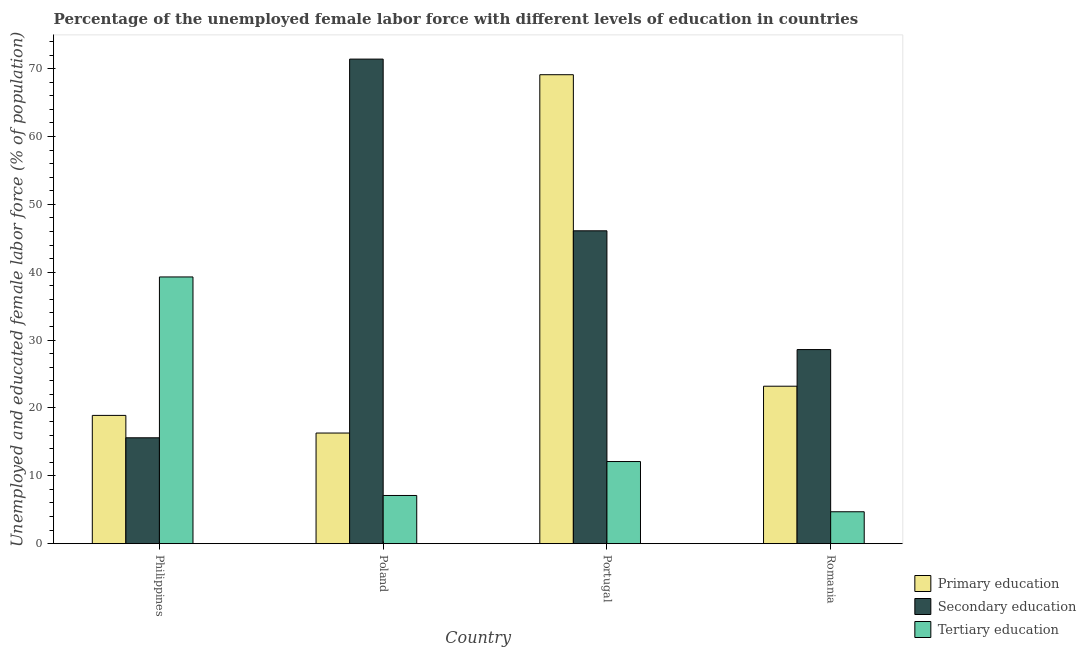How many different coloured bars are there?
Your answer should be compact. 3. Are the number of bars per tick equal to the number of legend labels?
Make the answer very short. Yes. Are the number of bars on each tick of the X-axis equal?
Give a very brief answer. Yes. What is the label of the 1st group of bars from the left?
Make the answer very short. Philippines. What is the percentage of female labor force who received primary education in Philippines?
Your answer should be compact. 18.9. Across all countries, what is the maximum percentage of female labor force who received secondary education?
Provide a succinct answer. 71.4. Across all countries, what is the minimum percentage of female labor force who received tertiary education?
Your answer should be compact. 4.7. In which country was the percentage of female labor force who received tertiary education maximum?
Your answer should be very brief. Philippines. In which country was the percentage of female labor force who received secondary education minimum?
Your response must be concise. Philippines. What is the total percentage of female labor force who received secondary education in the graph?
Keep it short and to the point. 161.7. What is the difference between the percentage of female labor force who received tertiary education in Portugal and that in Romania?
Your answer should be compact. 7.4. What is the difference between the percentage of female labor force who received secondary education in Portugal and the percentage of female labor force who received tertiary education in Poland?
Offer a terse response. 39. What is the average percentage of female labor force who received tertiary education per country?
Your answer should be compact. 15.8. What is the difference between the percentage of female labor force who received tertiary education and percentage of female labor force who received primary education in Poland?
Your response must be concise. -9.2. What is the ratio of the percentage of female labor force who received secondary education in Philippines to that in Romania?
Provide a succinct answer. 0.55. Is the percentage of female labor force who received secondary education in Poland less than that in Romania?
Offer a terse response. No. Is the difference between the percentage of female labor force who received secondary education in Poland and Romania greater than the difference between the percentage of female labor force who received tertiary education in Poland and Romania?
Offer a very short reply. Yes. What is the difference between the highest and the second highest percentage of female labor force who received primary education?
Give a very brief answer. 45.9. What is the difference between the highest and the lowest percentage of female labor force who received primary education?
Ensure brevity in your answer.  52.8. In how many countries, is the percentage of female labor force who received secondary education greater than the average percentage of female labor force who received secondary education taken over all countries?
Offer a terse response. 2. Is the sum of the percentage of female labor force who received primary education in Philippines and Portugal greater than the maximum percentage of female labor force who received secondary education across all countries?
Offer a terse response. Yes. What does the 1st bar from the left in Philippines represents?
Offer a very short reply. Primary education. What does the 2nd bar from the right in Philippines represents?
Your response must be concise. Secondary education. Is it the case that in every country, the sum of the percentage of female labor force who received primary education and percentage of female labor force who received secondary education is greater than the percentage of female labor force who received tertiary education?
Keep it short and to the point. No. Are all the bars in the graph horizontal?
Offer a terse response. No. What is the difference between two consecutive major ticks on the Y-axis?
Offer a very short reply. 10. Are the values on the major ticks of Y-axis written in scientific E-notation?
Provide a short and direct response. No. Does the graph contain any zero values?
Offer a terse response. No. Does the graph contain grids?
Provide a succinct answer. No. What is the title of the graph?
Keep it short and to the point. Percentage of the unemployed female labor force with different levels of education in countries. Does "Food" appear as one of the legend labels in the graph?
Your answer should be compact. No. What is the label or title of the X-axis?
Your response must be concise. Country. What is the label or title of the Y-axis?
Your answer should be very brief. Unemployed and educated female labor force (% of population). What is the Unemployed and educated female labor force (% of population) of Primary education in Philippines?
Your answer should be compact. 18.9. What is the Unemployed and educated female labor force (% of population) of Secondary education in Philippines?
Make the answer very short. 15.6. What is the Unemployed and educated female labor force (% of population) of Tertiary education in Philippines?
Your response must be concise. 39.3. What is the Unemployed and educated female labor force (% of population) of Primary education in Poland?
Offer a terse response. 16.3. What is the Unemployed and educated female labor force (% of population) in Secondary education in Poland?
Offer a terse response. 71.4. What is the Unemployed and educated female labor force (% of population) of Tertiary education in Poland?
Your answer should be very brief. 7.1. What is the Unemployed and educated female labor force (% of population) in Primary education in Portugal?
Provide a succinct answer. 69.1. What is the Unemployed and educated female labor force (% of population) of Secondary education in Portugal?
Offer a very short reply. 46.1. What is the Unemployed and educated female labor force (% of population) in Tertiary education in Portugal?
Your answer should be compact. 12.1. What is the Unemployed and educated female labor force (% of population) in Primary education in Romania?
Keep it short and to the point. 23.2. What is the Unemployed and educated female labor force (% of population) in Secondary education in Romania?
Offer a terse response. 28.6. What is the Unemployed and educated female labor force (% of population) in Tertiary education in Romania?
Make the answer very short. 4.7. Across all countries, what is the maximum Unemployed and educated female labor force (% of population) in Primary education?
Ensure brevity in your answer.  69.1. Across all countries, what is the maximum Unemployed and educated female labor force (% of population) of Secondary education?
Give a very brief answer. 71.4. Across all countries, what is the maximum Unemployed and educated female labor force (% of population) in Tertiary education?
Your answer should be compact. 39.3. Across all countries, what is the minimum Unemployed and educated female labor force (% of population) in Primary education?
Your answer should be compact. 16.3. Across all countries, what is the minimum Unemployed and educated female labor force (% of population) of Secondary education?
Your answer should be compact. 15.6. Across all countries, what is the minimum Unemployed and educated female labor force (% of population) in Tertiary education?
Offer a very short reply. 4.7. What is the total Unemployed and educated female labor force (% of population) of Primary education in the graph?
Make the answer very short. 127.5. What is the total Unemployed and educated female labor force (% of population) in Secondary education in the graph?
Offer a terse response. 161.7. What is the total Unemployed and educated female labor force (% of population) in Tertiary education in the graph?
Offer a very short reply. 63.2. What is the difference between the Unemployed and educated female labor force (% of population) in Primary education in Philippines and that in Poland?
Offer a very short reply. 2.6. What is the difference between the Unemployed and educated female labor force (% of population) in Secondary education in Philippines and that in Poland?
Your answer should be compact. -55.8. What is the difference between the Unemployed and educated female labor force (% of population) of Tertiary education in Philippines and that in Poland?
Keep it short and to the point. 32.2. What is the difference between the Unemployed and educated female labor force (% of population) in Primary education in Philippines and that in Portugal?
Your answer should be compact. -50.2. What is the difference between the Unemployed and educated female labor force (% of population) in Secondary education in Philippines and that in Portugal?
Make the answer very short. -30.5. What is the difference between the Unemployed and educated female labor force (% of population) in Tertiary education in Philippines and that in Portugal?
Offer a very short reply. 27.2. What is the difference between the Unemployed and educated female labor force (% of population) in Primary education in Philippines and that in Romania?
Provide a succinct answer. -4.3. What is the difference between the Unemployed and educated female labor force (% of population) of Tertiary education in Philippines and that in Romania?
Your response must be concise. 34.6. What is the difference between the Unemployed and educated female labor force (% of population) in Primary education in Poland and that in Portugal?
Your answer should be compact. -52.8. What is the difference between the Unemployed and educated female labor force (% of population) in Secondary education in Poland and that in Portugal?
Offer a very short reply. 25.3. What is the difference between the Unemployed and educated female labor force (% of population) of Tertiary education in Poland and that in Portugal?
Make the answer very short. -5. What is the difference between the Unemployed and educated female labor force (% of population) of Secondary education in Poland and that in Romania?
Offer a terse response. 42.8. What is the difference between the Unemployed and educated female labor force (% of population) in Primary education in Portugal and that in Romania?
Make the answer very short. 45.9. What is the difference between the Unemployed and educated female labor force (% of population) in Tertiary education in Portugal and that in Romania?
Your response must be concise. 7.4. What is the difference between the Unemployed and educated female labor force (% of population) in Primary education in Philippines and the Unemployed and educated female labor force (% of population) in Secondary education in Poland?
Your answer should be compact. -52.5. What is the difference between the Unemployed and educated female labor force (% of population) in Primary education in Philippines and the Unemployed and educated female labor force (% of population) in Tertiary education in Poland?
Ensure brevity in your answer.  11.8. What is the difference between the Unemployed and educated female labor force (% of population) of Secondary education in Philippines and the Unemployed and educated female labor force (% of population) of Tertiary education in Poland?
Make the answer very short. 8.5. What is the difference between the Unemployed and educated female labor force (% of population) of Primary education in Philippines and the Unemployed and educated female labor force (% of population) of Secondary education in Portugal?
Provide a succinct answer. -27.2. What is the difference between the Unemployed and educated female labor force (% of population) in Primary education in Philippines and the Unemployed and educated female labor force (% of population) in Tertiary education in Portugal?
Give a very brief answer. 6.8. What is the difference between the Unemployed and educated female labor force (% of population) of Primary education in Philippines and the Unemployed and educated female labor force (% of population) of Secondary education in Romania?
Ensure brevity in your answer.  -9.7. What is the difference between the Unemployed and educated female labor force (% of population) in Secondary education in Philippines and the Unemployed and educated female labor force (% of population) in Tertiary education in Romania?
Give a very brief answer. 10.9. What is the difference between the Unemployed and educated female labor force (% of population) in Primary education in Poland and the Unemployed and educated female labor force (% of population) in Secondary education in Portugal?
Provide a short and direct response. -29.8. What is the difference between the Unemployed and educated female labor force (% of population) in Primary education in Poland and the Unemployed and educated female labor force (% of population) in Tertiary education in Portugal?
Offer a terse response. 4.2. What is the difference between the Unemployed and educated female labor force (% of population) of Secondary education in Poland and the Unemployed and educated female labor force (% of population) of Tertiary education in Portugal?
Make the answer very short. 59.3. What is the difference between the Unemployed and educated female labor force (% of population) of Primary education in Poland and the Unemployed and educated female labor force (% of population) of Tertiary education in Romania?
Ensure brevity in your answer.  11.6. What is the difference between the Unemployed and educated female labor force (% of population) of Secondary education in Poland and the Unemployed and educated female labor force (% of population) of Tertiary education in Romania?
Offer a very short reply. 66.7. What is the difference between the Unemployed and educated female labor force (% of population) in Primary education in Portugal and the Unemployed and educated female labor force (% of population) in Secondary education in Romania?
Make the answer very short. 40.5. What is the difference between the Unemployed and educated female labor force (% of population) in Primary education in Portugal and the Unemployed and educated female labor force (% of population) in Tertiary education in Romania?
Offer a terse response. 64.4. What is the difference between the Unemployed and educated female labor force (% of population) in Secondary education in Portugal and the Unemployed and educated female labor force (% of population) in Tertiary education in Romania?
Provide a short and direct response. 41.4. What is the average Unemployed and educated female labor force (% of population) in Primary education per country?
Keep it short and to the point. 31.88. What is the average Unemployed and educated female labor force (% of population) of Secondary education per country?
Provide a succinct answer. 40.42. What is the difference between the Unemployed and educated female labor force (% of population) of Primary education and Unemployed and educated female labor force (% of population) of Secondary education in Philippines?
Give a very brief answer. 3.3. What is the difference between the Unemployed and educated female labor force (% of population) in Primary education and Unemployed and educated female labor force (% of population) in Tertiary education in Philippines?
Ensure brevity in your answer.  -20.4. What is the difference between the Unemployed and educated female labor force (% of population) in Secondary education and Unemployed and educated female labor force (% of population) in Tertiary education in Philippines?
Your answer should be very brief. -23.7. What is the difference between the Unemployed and educated female labor force (% of population) in Primary education and Unemployed and educated female labor force (% of population) in Secondary education in Poland?
Your response must be concise. -55.1. What is the difference between the Unemployed and educated female labor force (% of population) of Primary education and Unemployed and educated female labor force (% of population) of Tertiary education in Poland?
Your answer should be compact. 9.2. What is the difference between the Unemployed and educated female labor force (% of population) of Secondary education and Unemployed and educated female labor force (% of population) of Tertiary education in Poland?
Provide a short and direct response. 64.3. What is the difference between the Unemployed and educated female labor force (% of population) in Primary education and Unemployed and educated female labor force (% of population) in Secondary education in Portugal?
Make the answer very short. 23. What is the difference between the Unemployed and educated female labor force (% of population) in Primary education and Unemployed and educated female labor force (% of population) in Tertiary education in Portugal?
Your response must be concise. 57. What is the difference between the Unemployed and educated female labor force (% of population) in Secondary education and Unemployed and educated female labor force (% of population) in Tertiary education in Portugal?
Ensure brevity in your answer.  34. What is the difference between the Unemployed and educated female labor force (% of population) of Primary education and Unemployed and educated female labor force (% of population) of Secondary education in Romania?
Provide a succinct answer. -5.4. What is the difference between the Unemployed and educated female labor force (% of population) of Primary education and Unemployed and educated female labor force (% of population) of Tertiary education in Romania?
Make the answer very short. 18.5. What is the difference between the Unemployed and educated female labor force (% of population) of Secondary education and Unemployed and educated female labor force (% of population) of Tertiary education in Romania?
Offer a very short reply. 23.9. What is the ratio of the Unemployed and educated female labor force (% of population) in Primary education in Philippines to that in Poland?
Keep it short and to the point. 1.16. What is the ratio of the Unemployed and educated female labor force (% of population) of Secondary education in Philippines to that in Poland?
Ensure brevity in your answer.  0.22. What is the ratio of the Unemployed and educated female labor force (% of population) of Tertiary education in Philippines to that in Poland?
Your answer should be compact. 5.54. What is the ratio of the Unemployed and educated female labor force (% of population) of Primary education in Philippines to that in Portugal?
Your answer should be compact. 0.27. What is the ratio of the Unemployed and educated female labor force (% of population) of Secondary education in Philippines to that in Portugal?
Give a very brief answer. 0.34. What is the ratio of the Unemployed and educated female labor force (% of population) in Tertiary education in Philippines to that in Portugal?
Give a very brief answer. 3.25. What is the ratio of the Unemployed and educated female labor force (% of population) of Primary education in Philippines to that in Romania?
Your response must be concise. 0.81. What is the ratio of the Unemployed and educated female labor force (% of population) in Secondary education in Philippines to that in Romania?
Keep it short and to the point. 0.55. What is the ratio of the Unemployed and educated female labor force (% of population) in Tertiary education in Philippines to that in Romania?
Make the answer very short. 8.36. What is the ratio of the Unemployed and educated female labor force (% of population) in Primary education in Poland to that in Portugal?
Ensure brevity in your answer.  0.24. What is the ratio of the Unemployed and educated female labor force (% of population) in Secondary education in Poland to that in Portugal?
Make the answer very short. 1.55. What is the ratio of the Unemployed and educated female labor force (% of population) in Tertiary education in Poland to that in Portugal?
Keep it short and to the point. 0.59. What is the ratio of the Unemployed and educated female labor force (% of population) in Primary education in Poland to that in Romania?
Offer a very short reply. 0.7. What is the ratio of the Unemployed and educated female labor force (% of population) of Secondary education in Poland to that in Romania?
Your answer should be very brief. 2.5. What is the ratio of the Unemployed and educated female labor force (% of population) in Tertiary education in Poland to that in Romania?
Make the answer very short. 1.51. What is the ratio of the Unemployed and educated female labor force (% of population) in Primary education in Portugal to that in Romania?
Keep it short and to the point. 2.98. What is the ratio of the Unemployed and educated female labor force (% of population) in Secondary education in Portugal to that in Romania?
Offer a terse response. 1.61. What is the ratio of the Unemployed and educated female labor force (% of population) in Tertiary education in Portugal to that in Romania?
Your answer should be compact. 2.57. What is the difference between the highest and the second highest Unemployed and educated female labor force (% of population) of Primary education?
Your answer should be very brief. 45.9. What is the difference between the highest and the second highest Unemployed and educated female labor force (% of population) of Secondary education?
Offer a terse response. 25.3. What is the difference between the highest and the second highest Unemployed and educated female labor force (% of population) of Tertiary education?
Make the answer very short. 27.2. What is the difference between the highest and the lowest Unemployed and educated female labor force (% of population) of Primary education?
Ensure brevity in your answer.  52.8. What is the difference between the highest and the lowest Unemployed and educated female labor force (% of population) of Secondary education?
Provide a short and direct response. 55.8. What is the difference between the highest and the lowest Unemployed and educated female labor force (% of population) in Tertiary education?
Ensure brevity in your answer.  34.6. 